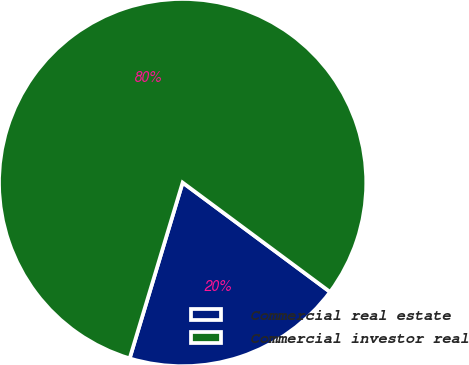Convert chart. <chart><loc_0><loc_0><loc_500><loc_500><pie_chart><fcel>Commercial real estate<fcel>Commercial investor real<nl><fcel>19.5%<fcel>80.5%<nl></chart> 